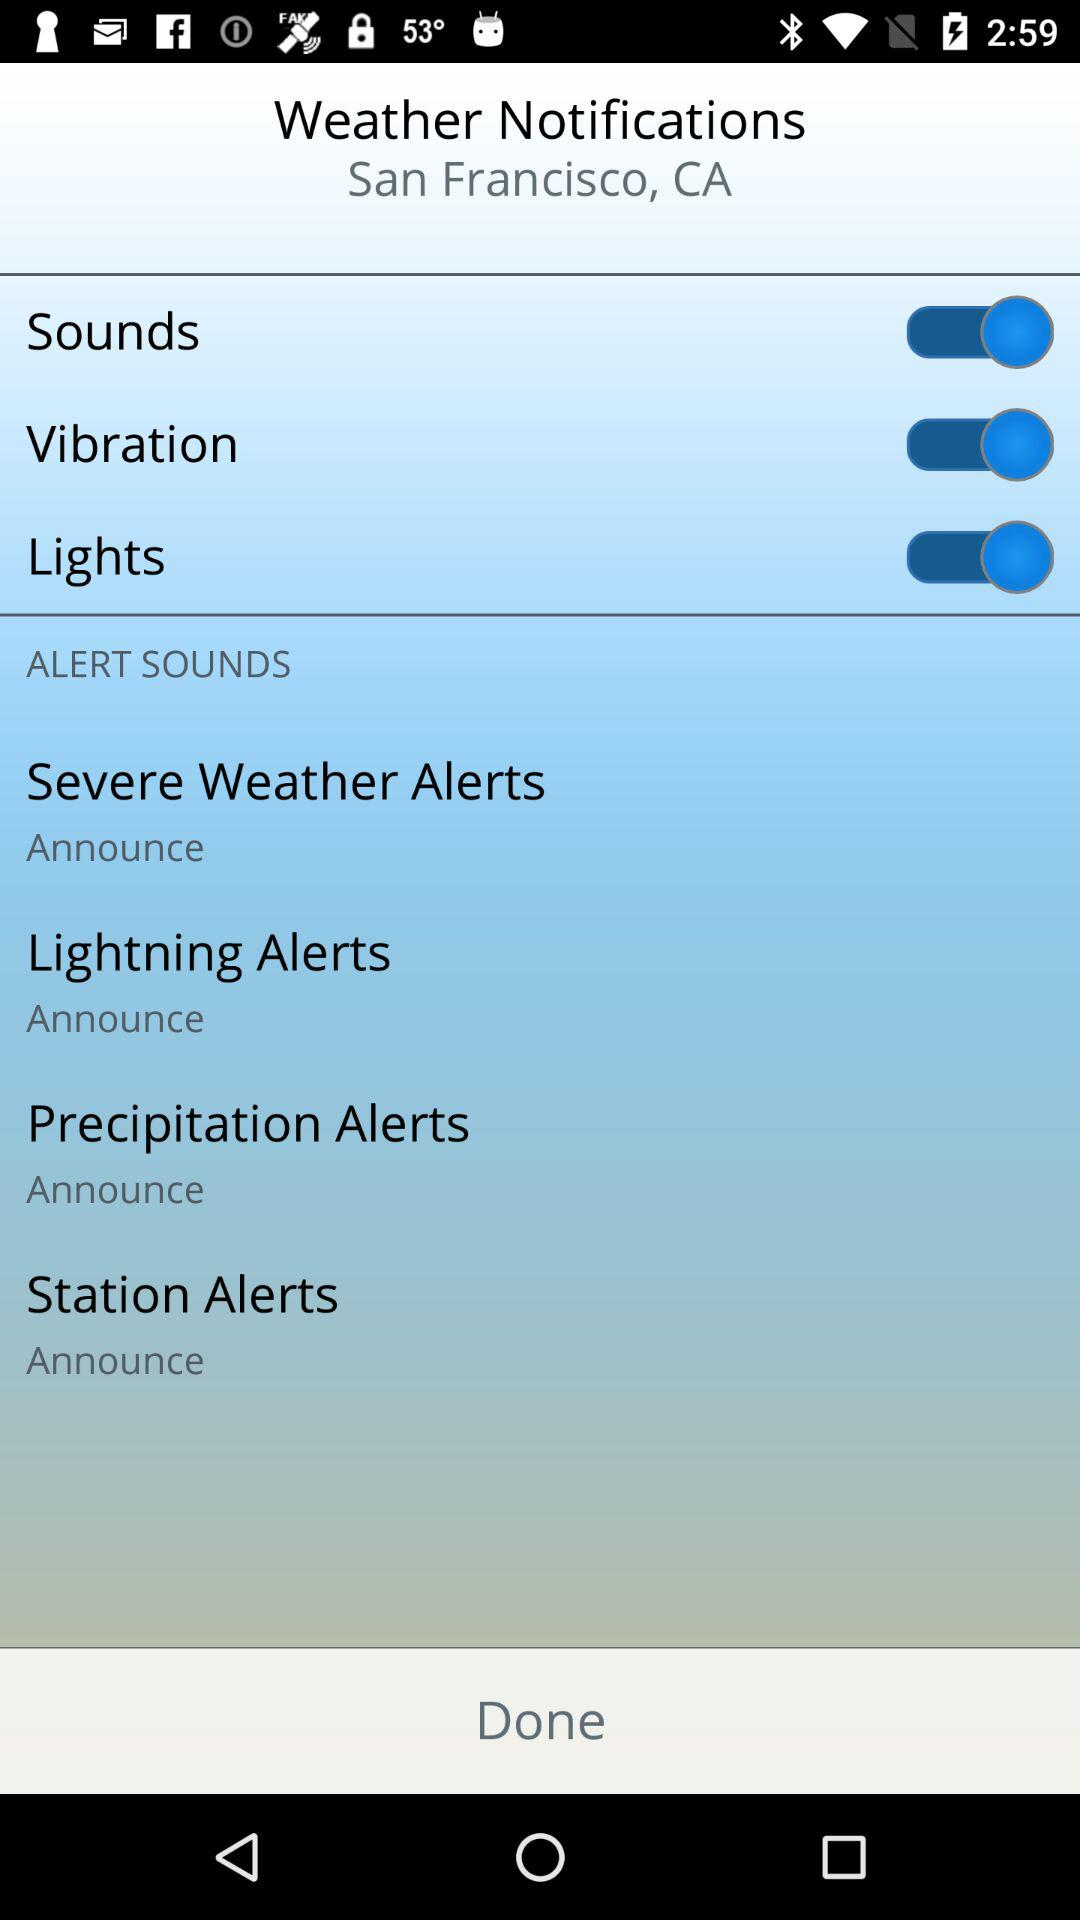What is the status of the "Vibration"? The status of the "Vibration" is "on". 